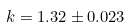Convert formula to latex. <formula><loc_0><loc_0><loc_500><loc_500>k = 1 . 3 2 \pm 0 . 0 2 3</formula> 